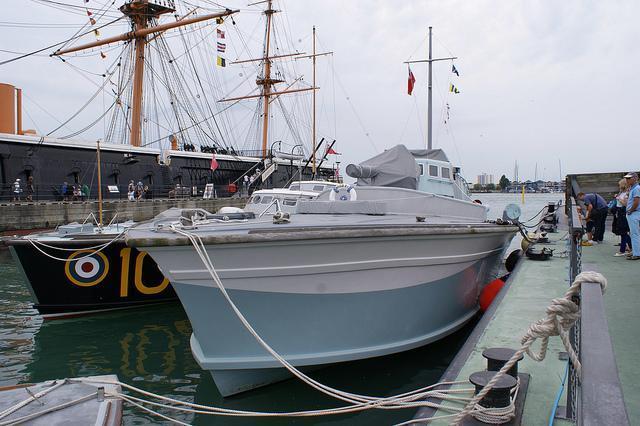How many boats are parked?
Give a very brief answer. 2. How many boats are in the photo?
Give a very brief answer. 2. How many white horses are there?
Give a very brief answer. 0. 